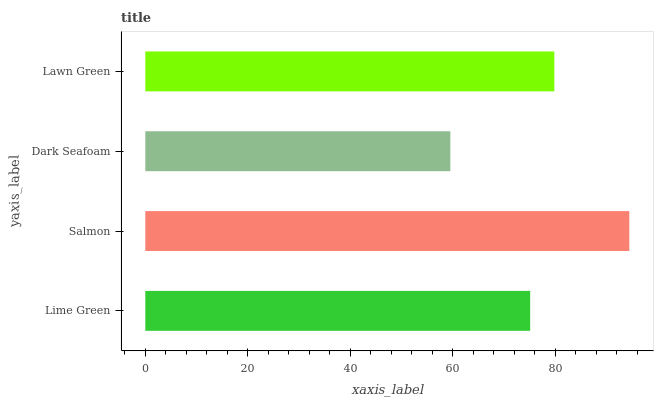Is Dark Seafoam the minimum?
Answer yes or no. Yes. Is Salmon the maximum?
Answer yes or no. Yes. Is Salmon the minimum?
Answer yes or no. No. Is Dark Seafoam the maximum?
Answer yes or no. No. Is Salmon greater than Dark Seafoam?
Answer yes or no. Yes. Is Dark Seafoam less than Salmon?
Answer yes or no. Yes. Is Dark Seafoam greater than Salmon?
Answer yes or no. No. Is Salmon less than Dark Seafoam?
Answer yes or no. No. Is Lawn Green the high median?
Answer yes or no. Yes. Is Lime Green the low median?
Answer yes or no. Yes. Is Salmon the high median?
Answer yes or no. No. Is Salmon the low median?
Answer yes or no. No. 